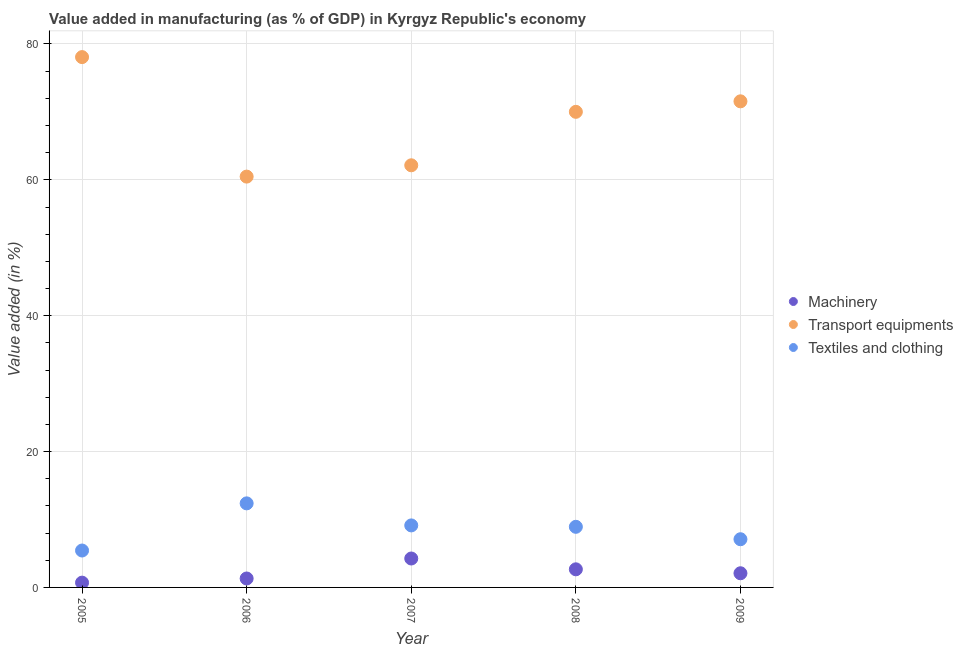What is the value added in manufacturing textile and clothing in 2007?
Keep it short and to the point. 9.13. Across all years, what is the maximum value added in manufacturing textile and clothing?
Your response must be concise. 12.37. Across all years, what is the minimum value added in manufacturing machinery?
Provide a short and direct response. 0.7. In which year was the value added in manufacturing machinery maximum?
Make the answer very short. 2007. In which year was the value added in manufacturing machinery minimum?
Keep it short and to the point. 2005. What is the total value added in manufacturing transport equipments in the graph?
Your response must be concise. 342.26. What is the difference between the value added in manufacturing textile and clothing in 2007 and that in 2008?
Make the answer very short. 0.21. What is the difference between the value added in manufacturing textile and clothing in 2007 and the value added in manufacturing machinery in 2006?
Your answer should be compact. 7.82. What is the average value added in manufacturing machinery per year?
Your answer should be very brief. 2.21. In the year 2008, what is the difference between the value added in manufacturing machinery and value added in manufacturing transport equipments?
Provide a succinct answer. -67.34. In how many years, is the value added in manufacturing textile and clothing greater than 36 %?
Make the answer very short. 0. What is the ratio of the value added in manufacturing machinery in 2005 to that in 2007?
Provide a short and direct response. 0.17. Is the difference between the value added in manufacturing textile and clothing in 2007 and 2008 greater than the difference between the value added in manufacturing machinery in 2007 and 2008?
Your response must be concise. No. What is the difference between the highest and the second highest value added in manufacturing machinery?
Provide a succinct answer. 1.59. What is the difference between the highest and the lowest value added in manufacturing textile and clothing?
Make the answer very short. 6.94. Is the sum of the value added in manufacturing machinery in 2008 and 2009 greater than the maximum value added in manufacturing transport equipments across all years?
Provide a succinct answer. No. Is it the case that in every year, the sum of the value added in manufacturing machinery and value added in manufacturing transport equipments is greater than the value added in manufacturing textile and clothing?
Keep it short and to the point. Yes. Is the value added in manufacturing machinery strictly greater than the value added in manufacturing transport equipments over the years?
Provide a succinct answer. No. Is the value added in manufacturing textile and clothing strictly less than the value added in manufacturing transport equipments over the years?
Give a very brief answer. Yes. Where does the legend appear in the graph?
Keep it short and to the point. Center right. How many legend labels are there?
Offer a very short reply. 3. How are the legend labels stacked?
Your answer should be very brief. Vertical. What is the title of the graph?
Your response must be concise. Value added in manufacturing (as % of GDP) in Kyrgyz Republic's economy. Does "Natural Gas" appear as one of the legend labels in the graph?
Your answer should be very brief. No. What is the label or title of the Y-axis?
Offer a terse response. Value added (in %). What is the Value added (in %) in Machinery in 2005?
Make the answer very short. 0.7. What is the Value added (in %) of Transport equipments in 2005?
Provide a succinct answer. 78.07. What is the Value added (in %) of Textiles and clothing in 2005?
Offer a terse response. 5.43. What is the Value added (in %) in Machinery in 2006?
Your answer should be compact. 1.31. What is the Value added (in %) in Transport equipments in 2006?
Keep it short and to the point. 60.48. What is the Value added (in %) in Textiles and clothing in 2006?
Provide a short and direct response. 12.37. What is the Value added (in %) of Machinery in 2007?
Offer a very short reply. 4.26. What is the Value added (in %) in Transport equipments in 2007?
Your response must be concise. 62.14. What is the Value added (in %) of Textiles and clothing in 2007?
Your response must be concise. 9.13. What is the Value added (in %) in Machinery in 2008?
Your answer should be compact. 2.67. What is the Value added (in %) in Transport equipments in 2008?
Give a very brief answer. 70.01. What is the Value added (in %) of Textiles and clothing in 2008?
Keep it short and to the point. 8.92. What is the Value added (in %) in Machinery in 2009?
Offer a very short reply. 2.09. What is the Value added (in %) of Transport equipments in 2009?
Provide a succinct answer. 71.56. What is the Value added (in %) of Textiles and clothing in 2009?
Your response must be concise. 7.09. Across all years, what is the maximum Value added (in %) of Machinery?
Offer a very short reply. 4.26. Across all years, what is the maximum Value added (in %) in Transport equipments?
Your answer should be very brief. 78.07. Across all years, what is the maximum Value added (in %) of Textiles and clothing?
Give a very brief answer. 12.37. Across all years, what is the minimum Value added (in %) in Machinery?
Keep it short and to the point. 0.7. Across all years, what is the minimum Value added (in %) in Transport equipments?
Keep it short and to the point. 60.48. Across all years, what is the minimum Value added (in %) of Textiles and clothing?
Your answer should be compact. 5.43. What is the total Value added (in %) in Machinery in the graph?
Your response must be concise. 11.03. What is the total Value added (in %) of Transport equipments in the graph?
Provide a short and direct response. 342.26. What is the total Value added (in %) in Textiles and clothing in the graph?
Ensure brevity in your answer.  42.96. What is the difference between the Value added (in %) in Machinery in 2005 and that in 2006?
Your answer should be compact. -0.61. What is the difference between the Value added (in %) of Transport equipments in 2005 and that in 2006?
Ensure brevity in your answer.  17.59. What is the difference between the Value added (in %) of Textiles and clothing in 2005 and that in 2006?
Your answer should be very brief. -6.94. What is the difference between the Value added (in %) in Machinery in 2005 and that in 2007?
Make the answer very short. -3.55. What is the difference between the Value added (in %) of Transport equipments in 2005 and that in 2007?
Give a very brief answer. 15.93. What is the difference between the Value added (in %) in Textiles and clothing in 2005 and that in 2007?
Keep it short and to the point. -3.7. What is the difference between the Value added (in %) of Machinery in 2005 and that in 2008?
Ensure brevity in your answer.  -1.96. What is the difference between the Value added (in %) of Transport equipments in 2005 and that in 2008?
Your answer should be compact. 8.06. What is the difference between the Value added (in %) in Textiles and clothing in 2005 and that in 2008?
Give a very brief answer. -3.49. What is the difference between the Value added (in %) in Machinery in 2005 and that in 2009?
Your response must be concise. -1.38. What is the difference between the Value added (in %) of Transport equipments in 2005 and that in 2009?
Make the answer very short. 6.51. What is the difference between the Value added (in %) of Textiles and clothing in 2005 and that in 2009?
Your response must be concise. -1.66. What is the difference between the Value added (in %) in Machinery in 2006 and that in 2007?
Your response must be concise. -2.94. What is the difference between the Value added (in %) in Transport equipments in 2006 and that in 2007?
Offer a very short reply. -1.67. What is the difference between the Value added (in %) of Textiles and clothing in 2006 and that in 2007?
Provide a short and direct response. 3.25. What is the difference between the Value added (in %) of Machinery in 2006 and that in 2008?
Provide a short and direct response. -1.35. What is the difference between the Value added (in %) of Transport equipments in 2006 and that in 2008?
Keep it short and to the point. -9.54. What is the difference between the Value added (in %) in Textiles and clothing in 2006 and that in 2008?
Give a very brief answer. 3.45. What is the difference between the Value added (in %) of Machinery in 2006 and that in 2009?
Provide a succinct answer. -0.77. What is the difference between the Value added (in %) of Transport equipments in 2006 and that in 2009?
Your answer should be very brief. -11.08. What is the difference between the Value added (in %) in Textiles and clothing in 2006 and that in 2009?
Make the answer very short. 5.28. What is the difference between the Value added (in %) of Machinery in 2007 and that in 2008?
Provide a succinct answer. 1.59. What is the difference between the Value added (in %) of Transport equipments in 2007 and that in 2008?
Your response must be concise. -7.87. What is the difference between the Value added (in %) of Textiles and clothing in 2007 and that in 2008?
Offer a terse response. 0.21. What is the difference between the Value added (in %) of Machinery in 2007 and that in 2009?
Your answer should be compact. 2.17. What is the difference between the Value added (in %) in Transport equipments in 2007 and that in 2009?
Offer a terse response. -9.42. What is the difference between the Value added (in %) in Textiles and clothing in 2007 and that in 2009?
Keep it short and to the point. 2.03. What is the difference between the Value added (in %) in Machinery in 2008 and that in 2009?
Your response must be concise. 0.58. What is the difference between the Value added (in %) of Transport equipments in 2008 and that in 2009?
Ensure brevity in your answer.  -1.55. What is the difference between the Value added (in %) of Textiles and clothing in 2008 and that in 2009?
Ensure brevity in your answer.  1.83. What is the difference between the Value added (in %) of Machinery in 2005 and the Value added (in %) of Transport equipments in 2006?
Offer a terse response. -59.77. What is the difference between the Value added (in %) in Machinery in 2005 and the Value added (in %) in Textiles and clothing in 2006?
Provide a short and direct response. -11.67. What is the difference between the Value added (in %) in Transport equipments in 2005 and the Value added (in %) in Textiles and clothing in 2006?
Your response must be concise. 65.69. What is the difference between the Value added (in %) of Machinery in 2005 and the Value added (in %) of Transport equipments in 2007?
Offer a very short reply. -61.44. What is the difference between the Value added (in %) in Machinery in 2005 and the Value added (in %) in Textiles and clothing in 2007?
Your answer should be very brief. -8.43. What is the difference between the Value added (in %) in Transport equipments in 2005 and the Value added (in %) in Textiles and clothing in 2007?
Your answer should be compact. 68.94. What is the difference between the Value added (in %) in Machinery in 2005 and the Value added (in %) in Transport equipments in 2008?
Make the answer very short. -69.31. What is the difference between the Value added (in %) of Machinery in 2005 and the Value added (in %) of Textiles and clothing in 2008?
Offer a terse response. -8.22. What is the difference between the Value added (in %) in Transport equipments in 2005 and the Value added (in %) in Textiles and clothing in 2008?
Provide a short and direct response. 69.15. What is the difference between the Value added (in %) of Machinery in 2005 and the Value added (in %) of Transport equipments in 2009?
Give a very brief answer. -70.85. What is the difference between the Value added (in %) of Machinery in 2005 and the Value added (in %) of Textiles and clothing in 2009?
Your answer should be very brief. -6.39. What is the difference between the Value added (in %) in Transport equipments in 2005 and the Value added (in %) in Textiles and clothing in 2009?
Your answer should be very brief. 70.97. What is the difference between the Value added (in %) in Machinery in 2006 and the Value added (in %) in Transport equipments in 2007?
Offer a very short reply. -60.83. What is the difference between the Value added (in %) in Machinery in 2006 and the Value added (in %) in Textiles and clothing in 2007?
Keep it short and to the point. -7.82. What is the difference between the Value added (in %) of Transport equipments in 2006 and the Value added (in %) of Textiles and clothing in 2007?
Your response must be concise. 51.35. What is the difference between the Value added (in %) in Machinery in 2006 and the Value added (in %) in Transport equipments in 2008?
Offer a very short reply. -68.7. What is the difference between the Value added (in %) in Machinery in 2006 and the Value added (in %) in Textiles and clothing in 2008?
Provide a short and direct response. -7.61. What is the difference between the Value added (in %) of Transport equipments in 2006 and the Value added (in %) of Textiles and clothing in 2008?
Your answer should be compact. 51.55. What is the difference between the Value added (in %) of Machinery in 2006 and the Value added (in %) of Transport equipments in 2009?
Provide a short and direct response. -70.24. What is the difference between the Value added (in %) in Machinery in 2006 and the Value added (in %) in Textiles and clothing in 2009?
Keep it short and to the point. -5.78. What is the difference between the Value added (in %) in Transport equipments in 2006 and the Value added (in %) in Textiles and clothing in 2009?
Provide a short and direct response. 53.38. What is the difference between the Value added (in %) in Machinery in 2007 and the Value added (in %) in Transport equipments in 2008?
Offer a terse response. -65.75. What is the difference between the Value added (in %) in Machinery in 2007 and the Value added (in %) in Textiles and clothing in 2008?
Your answer should be very brief. -4.67. What is the difference between the Value added (in %) in Transport equipments in 2007 and the Value added (in %) in Textiles and clothing in 2008?
Your answer should be very brief. 53.22. What is the difference between the Value added (in %) of Machinery in 2007 and the Value added (in %) of Transport equipments in 2009?
Your answer should be compact. -67.3. What is the difference between the Value added (in %) of Machinery in 2007 and the Value added (in %) of Textiles and clothing in 2009?
Your answer should be compact. -2.84. What is the difference between the Value added (in %) of Transport equipments in 2007 and the Value added (in %) of Textiles and clothing in 2009?
Provide a succinct answer. 55.05. What is the difference between the Value added (in %) in Machinery in 2008 and the Value added (in %) in Transport equipments in 2009?
Keep it short and to the point. -68.89. What is the difference between the Value added (in %) of Machinery in 2008 and the Value added (in %) of Textiles and clothing in 2009?
Offer a very short reply. -4.43. What is the difference between the Value added (in %) in Transport equipments in 2008 and the Value added (in %) in Textiles and clothing in 2009?
Make the answer very short. 62.92. What is the average Value added (in %) of Machinery per year?
Your answer should be very brief. 2.21. What is the average Value added (in %) in Transport equipments per year?
Your answer should be very brief. 68.45. What is the average Value added (in %) of Textiles and clothing per year?
Make the answer very short. 8.59. In the year 2005, what is the difference between the Value added (in %) in Machinery and Value added (in %) in Transport equipments?
Your response must be concise. -77.36. In the year 2005, what is the difference between the Value added (in %) of Machinery and Value added (in %) of Textiles and clothing?
Make the answer very short. -4.73. In the year 2005, what is the difference between the Value added (in %) of Transport equipments and Value added (in %) of Textiles and clothing?
Make the answer very short. 72.64. In the year 2006, what is the difference between the Value added (in %) of Machinery and Value added (in %) of Transport equipments?
Your response must be concise. -59.16. In the year 2006, what is the difference between the Value added (in %) of Machinery and Value added (in %) of Textiles and clothing?
Provide a succinct answer. -11.06. In the year 2006, what is the difference between the Value added (in %) in Transport equipments and Value added (in %) in Textiles and clothing?
Provide a succinct answer. 48.1. In the year 2007, what is the difference between the Value added (in %) of Machinery and Value added (in %) of Transport equipments?
Offer a very short reply. -57.88. In the year 2007, what is the difference between the Value added (in %) of Machinery and Value added (in %) of Textiles and clothing?
Your response must be concise. -4.87. In the year 2007, what is the difference between the Value added (in %) in Transport equipments and Value added (in %) in Textiles and clothing?
Your response must be concise. 53.01. In the year 2008, what is the difference between the Value added (in %) of Machinery and Value added (in %) of Transport equipments?
Your response must be concise. -67.34. In the year 2008, what is the difference between the Value added (in %) of Machinery and Value added (in %) of Textiles and clothing?
Your response must be concise. -6.26. In the year 2008, what is the difference between the Value added (in %) of Transport equipments and Value added (in %) of Textiles and clothing?
Keep it short and to the point. 61.09. In the year 2009, what is the difference between the Value added (in %) of Machinery and Value added (in %) of Transport equipments?
Offer a very short reply. -69.47. In the year 2009, what is the difference between the Value added (in %) of Machinery and Value added (in %) of Textiles and clothing?
Provide a short and direct response. -5.01. In the year 2009, what is the difference between the Value added (in %) of Transport equipments and Value added (in %) of Textiles and clothing?
Offer a terse response. 64.46. What is the ratio of the Value added (in %) of Machinery in 2005 to that in 2006?
Provide a short and direct response. 0.54. What is the ratio of the Value added (in %) of Transport equipments in 2005 to that in 2006?
Provide a succinct answer. 1.29. What is the ratio of the Value added (in %) in Textiles and clothing in 2005 to that in 2006?
Keep it short and to the point. 0.44. What is the ratio of the Value added (in %) in Machinery in 2005 to that in 2007?
Ensure brevity in your answer.  0.17. What is the ratio of the Value added (in %) of Transport equipments in 2005 to that in 2007?
Your response must be concise. 1.26. What is the ratio of the Value added (in %) in Textiles and clothing in 2005 to that in 2007?
Provide a short and direct response. 0.6. What is the ratio of the Value added (in %) in Machinery in 2005 to that in 2008?
Provide a short and direct response. 0.26. What is the ratio of the Value added (in %) in Transport equipments in 2005 to that in 2008?
Offer a terse response. 1.12. What is the ratio of the Value added (in %) in Textiles and clothing in 2005 to that in 2008?
Your answer should be compact. 0.61. What is the ratio of the Value added (in %) of Machinery in 2005 to that in 2009?
Your response must be concise. 0.34. What is the ratio of the Value added (in %) of Transport equipments in 2005 to that in 2009?
Make the answer very short. 1.09. What is the ratio of the Value added (in %) in Textiles and clothing in 2005 to that in 2009?
Keep it short and to the point. 0.77. What is the ratio of the Value added (in %) of Machinery in 2006 to that in 2007?
Ensure brevity in your answer.  0.31. What is the ratio of the Value added (in %) of Transport equipments in 2006 to that in 2007?
Offer a terse response. 0.97. What is the ratio of the Value added (in %) in Textiles and clothing in 2006 to that in 2007?
Your response must be concise. 1.36. What is the ratio of the Value added (in %) of Machinery in 2006 to that in 2008?
Your answer should be very brief. 0.49. What is the ratio of the Value added (in %) in Transport equipments in 2006 to that in 2008?
Keep it short and to the point. 0.86. What is the ratio of the Value added (in %) of Textiles and clothing in 2006 to that in 2008?
Offer a terse response. 1.39. What is the ratio of the Value added (in %) of Machinery in 2006 to that in 2009?
Offer a terse response. 0.63. What is the ratio of the Value added (in %) of Transport equipments in 2006 to that in 2009?
Your answer should be compact. 0.85. What is the ratio of the Value added (in %) of Textiles and clothing in 2006 to that in 2009?
Your answer should be very brief. 1.74. What is the ratio of the Value added (in %) of Machinery in 2007 to that in 2008?
Offer a very short reply. 1.6. What is the ratio of the Value added (in %) of Transport equipments in 2007 to that in 2008?
Your response must be concise. 0.89. What is the ratio of the Value added (in %) in Textiles and clothing in 2007 to that in 2008?
Ensure brevity in your answer.  1.02. What is the ratio of the Value added (in %) of Machinery in 2007 to that in 2009?
Your response must be concise. 2.04. What is the ratio of the Value added (in %) in Transport equipments in 2007 to that in 2009?
Your answer should be very brief. 0.87. What is the ratio of the Value added (in %) of Textiles and clothing in 2007 to that in 2009?
Keep it short and to the point. 1.29. What is the ratio of the Value added (in %) in Machinery in 2008 to that in 2009?
Your response must be concise. 1.28. What is the ratio of the Value added (in %) in Transport equipments in 2008 to that in 2009?
Offer a very short reply. 0.98. What is the ratio of the Value added (in %) in Textiles and clothing in 2008 to that in 2009?
Your answer should be very brief. 1.26. What is the difference between the highest and the second highest Value added (in %) of Machinery?
Your answer should be compact. 1.59. What is the difference between the highest and the second highest Value added (in %) in Transport equipments?
Give a very brief answer. 6.51. What is the difference between the highest and the second highest Value added (in %) in Textiles and clothing?
Your answer should be very brief. 3.25. What is the difference between the highest and the lowest Value added (in %) in Machinery?
Make the answer very short. 3.55. What is the difference between the highest and the lowest Value added (in %) in Transport equipments?
Your answer should be very brief. 17.59. What is the difference between the highest and the lowest Value added (in %) of Textiles and clothing?
Ensure brevity in your answer.  6.94. 